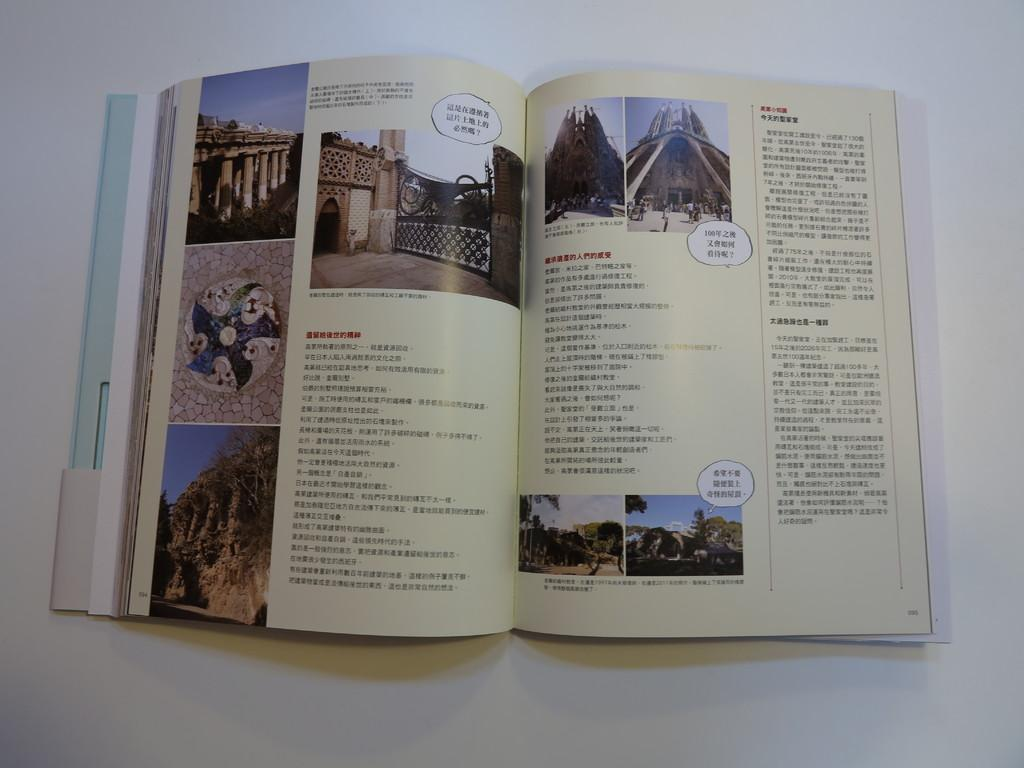What is the main object in the image? There is a book in the image. What is the color of the surface the book is on? The book is on a white surface. What types of images are included in the book? The book contains images of trees and buildings. Does the book only contain images, or does it also have text? The book contains text as well. How many nerves are visible in the image? There are no nerves visible in the image; it features a book with images of trees and buildings. What type of amusement can be seen in the image? There is no amusement present in the image; it features a book with images of trees and buildings. 